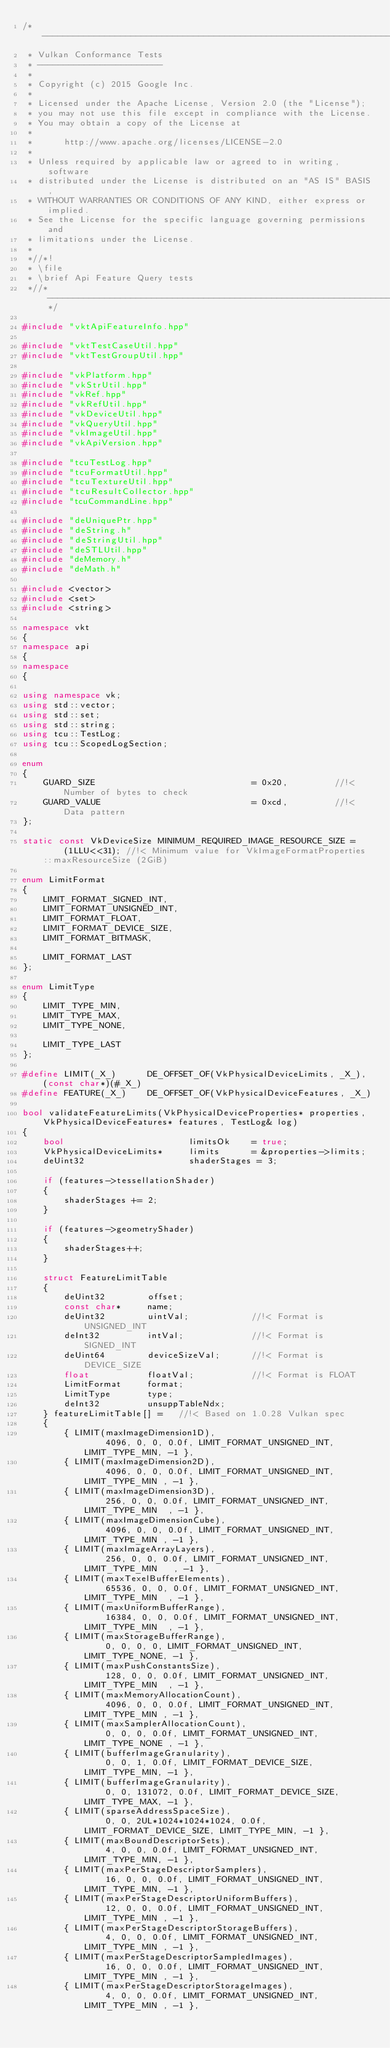Convert code to text. <code><loc_0><loc_0><loc_500><loc_500><_C++_>/*-------------------------------------------------------------------------
 * Vulkan Conformance Tests
 * ------------------------
 *
 * Copyright (c) 2015 Google Inc.
 *
 * Licensed under the Apache License, Version 2.0 (the "License");
 * you may not use this file except in compliance with the License.
 * You may obtain a copy of the License at
 *
 *      http://www.apache.org/licenses/LICENSE-2.0
 *
 * Unless required by applicable law or agreed to in writing, software
 * distributed under the License is distributed on an "AS IS" BASIS,
 * WITHOUT WARRANTIES OR CONDITIONS OF ANY KIND, either express or implied.
 * See the License for the specific language governing permissions and
 * limitations under the License.
 *
 *//*!
 * \file
 * \brief Api Feature Query tests
 *//*--------------------------------------------------------------------*/

#include "vktApiFeatureInfo.hpp"

#include "vktTestCaseUtil.hpp"
#include "vktTestGroupUtil.hpp"

#include "vkPlatform.hpp"
#include "vkStrUtil.hpp"
#include "vkRef.hpp"
#include "vkRefUtil.hpp"
#include "vkDeviceUtil.hpp"
#include "vkQueryUtil.hpp"
#include "vkImageUtil.hpp"
#include "vkApiVersion.hpp"

#include "tcuTestLog.hpp"
#include "tcuFormatUtil.hpp"
#include "tcuTextureUtil.hpp"
#include "tcuResultCollector.hpp"
#include "tcuCommandLine.hpp"

#include "deUniquePtr.hpp"
#include "deString.h"
#include "deStringUtil.hpp"
#include "deSTLUtil.hpp"
#include "deMemory.h"
#include "deMath.h"

#include <vector>
#include <set>
#include <string>

namespace vkt
{
namespace api
{
namespace
{

using namespace vk;
using std::vector;
using std::set;
using std::string;
using tcu::TestLog;
using tcu::ScopedLogSection;

enum
{
	GUARD_SIZE								= 0x20,			//!< Number of bytes to check
	GUARD_VALUE								= 0xcd,			//!< Data pattern
};

static const VkDeviceSize MINIMUM_REQUIRED_IMAGE_RESOURCE_SIZE =	(1LLU<<31);	//!< Minimum value for VkImageFormatProperties::maxResourceSize (2GiB)

enum LimitFormat
{
	LIMIT_FORMAT_SIGNED_INT,
	LIMIT_FORMAT_UNSIGNED_INT,
	LIMIT_FORMAT_FLOAT,
	LIMIT_FORMAT_DEVICE_SIZE,
	LIMIT_FORMAT_BITMASK,

	LIMIT_FORMAT_LAST
};

enum LimitType
{
	LIMIT_TYPE_MIN,
	LIMIT_TYPE_MAX,
	LIMIT_TYPE_NONE,

	LIMIT_TYPE_LAST
};

#define LIMIT(_X_)		DE_OFFSET_OF(VkPhysicalDeviceLimits, _X_), (const char*)(#_X_)
#define FEATURE(_X_)	DE_OFFSET_OF(VkPhysicalDeviceFeatures, _X_)

bool validateFeatureLimits(VkPhysicalDeviceProperties* properties, VkPhysicalDeviceFeatures* features, TestLog& log)
{
	bool						limitsOk	= true;
	VkPhysicalDeviceLimits*		limits		= &properties->limits;
	deUint32					shaderStages = 3;

	if (features->tessellationShader)
	{
		shaderStages += 2;
	}

	if (features->geometryShader)
	{
		shaderStages++;
	}

	struct FeatureLimitTable
	{
		deUint32		offset;
		const char*		name;
		deUint32		uintVal;			//!< Format is UNSIGNED_INT
		deInt32			intVal;				//!< Format is SIGNED_INT
		deUint64		deviceSizeVal;		//!< Format is DEVICE_SIZE
		float			floatVal;			//!< Format is FLOAT
		LimitFormat		format;
		LimitType		type;
		deInt32			unsuppTableNdx;
	} featureLimitTable[] =   //!< Based on 1.0.28 Vulkan spec
	{
		{ LIMIT(maxImageDimension1D),								4096, 0, 0, 0.0f, LIMIT_FORMAT_UNSIGNED_INT, LIMIT_TYPE_MIN, -1 },
		{ LIMIT(maxImageDimension2D),								4096, 0, 0, 0.0f, LIMIT_FORMAT_UNSIGNED_INT, LIMIT_TYPE_MIN , -1 },
		{ LIMIT(maxImageDimension3D),								256, 0, 0, 0.0f, LIMIT_FORMAT_UNSIGNED_INT, LIMIT_TYPE_MIN  , -1 },
		{ LIMIT(maxImageDimensionCube),								4096, 0, 0, 0.0f, LIMIT_FORMAT_UNSIGNED_INT, LIMIT_TYPE_MIN , -1 },
		{ LIMIT(maxImageArrayLayers),								256, 0, 0, 0.0f, LIMIT_FORMAT_UNSIGNED_INT, LIMIT_TYPE_MIN   , -1 },
		{ LIMIT(maxTexelBufferElements),							65536, 0, 0, 0.0f, LIMIT_FORMAT_UNSIGNED_INT, LIMIT_TYPE_MIN  , -1 },
		{ LIMIT(maxUniformBufferRange),								16384, 0, 0, 0.0f, LIMIT_FORMAT_UNSIGNED_INT, LIMIT_TYPE_MIN  , -1 },
		{ LIMIT(maxStorageBufferRange),								0, 0, 0, 0, LIMIT_FORMAT_UNSIGNED_INT, LIMIT_TYPE_NONE, -1 },
		{ LIMIT(maxPushConstantsSize),								128, 0, 0, 0.0f, LIMIT_FORMAT_UNSIGNED_INT, LIMIT_TYPE_MIN  , -1 },
		{ LIMIT(maxMemoryAllocationCount),							4096, 0, 0, 0.0f, LIMIT_FORMAT_UNSIGNED_INT, LIMIT_TYPE_MIN , -1 },
		{ LIMIT(maxSamplerAllocationCount),							0, 0, 0, 0.0f, LIMIT_FORMAT_UNSIGNED_INT, LIMIT_TYPE_NONE , -1 },
		{ LIMIT(bufferImageGranularity),							0, 0, 1, 0.0f, LIMIT_FORMAT_DEVICE_SIZE, LIMIT_TYPE_MIN, -1 },
		{ LIMIT(bufferImageGranularity),							0, 0, 131072, 0.0f, LIMIT_FORMAT_DEVICE_SIZE, LIMIT_TYPE_MAX, -1 },
		{ LIMIT(sparseAddressSpaceSize),							0, 0, 2UL*1024*1024*1024, 0.0f, LIMIT_FORMAT_DEVICE_SIZE, LIMIT_TYPE_MIN, -1 },
		{ LIMIT(maxBoundDescriptorSets),							4, 0, 0, 0.0f, LIMIT_FORMAT_UNSIGNED_INT, LIMIT_TYPE_MIN, -1 },
		{ LIMIT(maxPerStageDescriptorSamplers),						16, 0, 0, 0.0f, LIMIT_FORMAT_UNSIGNED_INT, LIMIT_TYPE_MIN, -1 },
		{ LIMIT(maxPerStageDescriptorUniformBuffers),				12, 0, 0, 0.0f, LIMIT_FORMAT_UNSIGNED_INT, LIMIT_TYPE_MIN , -1 },
		{ LIMIT(maxPerStageDescriptorStorageBuffers),				4, 0, 0, 0.0f, LIMIT_FORMAT_UNSIGNED_INT, LIMIT_TYPE_MIN , -1 },
		{ LIMIT(maxPerStageDescriptorSampledImages),				16, 0, 0, 0.0f, LIMIT_FORMAT_UNSIGNED_INT, LIMIT_TYPE_MIN , -1 },
		{ LIMIT(maxPerStageDescriptorStorageImages),				4, 0, 0, 0.0f, LIMIT_FORMAT_UNSIGNED_INT, LIMIT_TYPE_MIN , -1 },</code> 